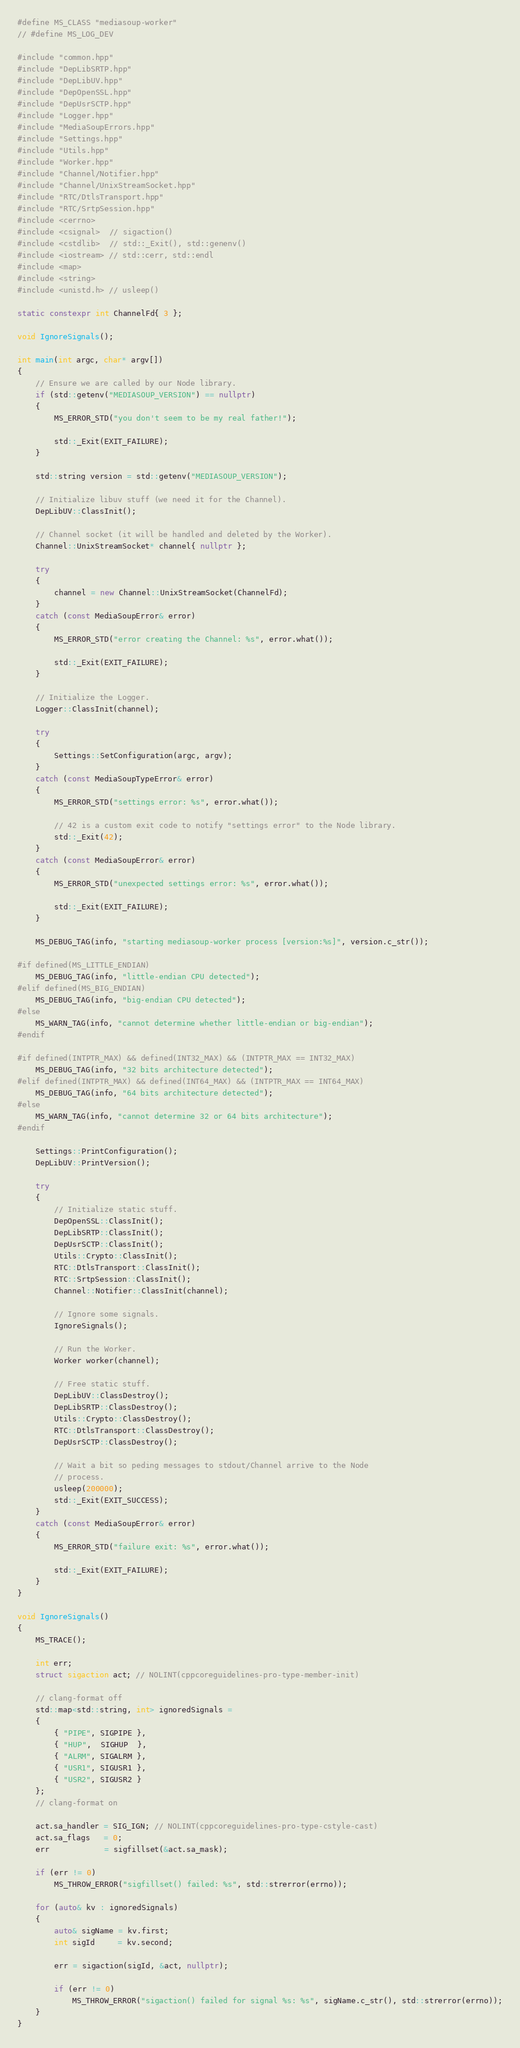Convert code to text. <code><loc_0><loc_0><loc_500><loc_500><_C++_>#define MS_CLASS "mediasoup-worker"
// #define MS_LOG_DEV

#include "common.hpp"
#include "DepLibSRTP.hpp"
#include "DepLibUV.hpp"
#include "DepOpenSSL.hpp"
#include "DepUsrSCTP.hpp"
#include "Logger.hpp"
#include "MediaSoupErrors.hpp"
#include "Settings.hpp"
#include "Utils.hpp"
#include "Worker.hpp"
#include "Channel/Notifier.hpp"
#include "Channel/UnixStreamSocket.hpp"
#include "RTC/DtlsTransport.hpp"
#include "RTC/SrtpSession.hpp"
#include <cerrno>
#include <csignal>  // sigaction()
#include <cstdlib>  // std::_Exit(), std::genenv()
#include <iostream> // std::cerr, std::endl
#include <map>
#include <string>
#include <unistd.h> // usleep()

static constexpr int ChannelFd{ 3 };

void IgnoreSignals();

int main(int argc, char* argv[])
{
	// Ensure we are called by our Node library.
	if (std::getenv("MEDIASOUP_VERSION") == nullptr)
	{
		MS_ERROR_STD("you don't seem to be my real father!");

		std::_Exit(EXIT_FAILURE);
	}

	std::string version = std::getenv("MEDIASOUP_VERSION");

	// Initialize libuv stuff (we need it for the Channel).
	DepLibUV::ClassInit();

	// Channel socket (it will be handled and deleted by the Worker).
	Channel::UnixStreamSocket* channel{ nullptr };

	try
	{
		channel = new Channel::UnixStreamSocket(ChannelFd);
	}
	catch (const MediaSoupError& error)
	{
		MS_ERROR_STD("error creating the Channel: %s", error.what());

		std::_Exit(EXIT_FAILURE);
	}

	// Initialize the Logger.
	Logger::ClassInit(channel);

	try
	{
		Settings::SetConfiguration(argc, argv);
	}
	catch (const MediaSoupTypeError& error)
	{
		MS_ERROR_STD("settings error: %s", error.what());

		// 42 is a custom exit code to notify "settings error" to the Node library.
		std::_Exit(42);
	}
	catch (const MediaSoupError& error)
	{
		MS_ERROR_STD("unexpected settings error: %s", error.what());

		std::_Exit(EXIT_FAILURE);
	}

	MS_DEBUG_TAG(info, "starting mediasoup-worker process [version:%s]", version.c_str());

#if defined(MS_LITTLE_ENDIAN)
	MS_DEBUG_TAG(info, "little-endian CPU detected");
#elif defined(MS_BIG_ENDIAN)
	MS_DEBUG_TAG(info, "big-endian CPU detected");
#else
	MS_WARN_TAG(info, "cannot determine whether little-endian or big-endian");
#endif

#if defined(INTPTR_MAX) && defined(INT32_MAX) && (INTPTR_MAX == INT32_MAX)
	MS_DEBUG_TAG(info, "32 bits architecture detected");
#elif defined(INTPTR_MAX) && defined(INT64_MAX) && (INTPTR_MAX == INT64_MAX)
	MS_DEBUG_TAG(info, "64 bits architecture detected");
#else
	MS_WARN_TAG(info, "cannot determine 32 or 64 bits architecture");
#endif

	Settings::PrintConfiguration();
	DepLibUV::PrintVersion();

	try
	{
		// Initialize static stuff.
		DepOpenSSL::ClassInit();
		DepLibSRTP::ClassInit();
		DepUsrSCTP::ClassInit();
		Utils::Crypto::ClassInit();
		RTC::DtlsTransport::ClassInit();
		RTC::SrtpSession::ClassInit();
		Channel::Notifier::ClassInit(channel);

		// Ignore some signals.
		IgnoreSignals();

		// Run the Worker.
		Worker worker(channel);

		// Free static stuff.
		DepLibUV::ClassDestroy();
		DepLibSRTP::ClassDestroy();
		Utils::Crypto::ClassDestroy();
		RTC::DtlsTransport::ClassDestroy();
		DepUsrSCTP::ClassDestroy();

		// Wait a bit so peding messages to stdout/Channel arrive to the Node
		// process.
		usleep(200000);
		std::_Exit(EXIT_SUCCESS);
	}
	catch (const MediaSoupError& error)
	{
		MS_ERROR_STD("failure exit: %s", error.what());

		std::_Exit(EXIT_FAILURE);
	}
}

void IgnoreSignals()
{
	MS_TRACE();

	int err;
	struct sigaction act; // NOLINT(cppcoreguidelines-pro-type-member-init)

	// clang-format off
	std::map<std::string, int> ignoredSignals =
	{
		{ "PIPE", SIGPIPE },
		{ "HUP",  SIGHUP  },
		{ "ALRM", SIGALRM },
		{ "USR1", SIGUSR1 },
		{ "USR2", SIGUSR2 }
	};
	// clang-format on

	act.sa_handler = SIG_IGN; // NOLINT(cppcoreguidelines-pro-type-cstyle-cast)
	act.sa_flags   = 0;
	err            = sigfillset(&act.sa_mask);

	if (err != 0)
		MS_THROW_ERROR("sigfillset() failed: %s", std::strerror(errno));

	for (auto& kv : ignoredSignals)
	{
		auto& sigName = kv.first;
		int sigId     = kv.second;

		err = sigaction(sigId, &act, nullptr);

		if (err != 0)
			MS_THROW_ERROR("sigaction() failed for signal %s: %s", sigName.c_str(), std::strerror(errno));
	}
}
</code> 